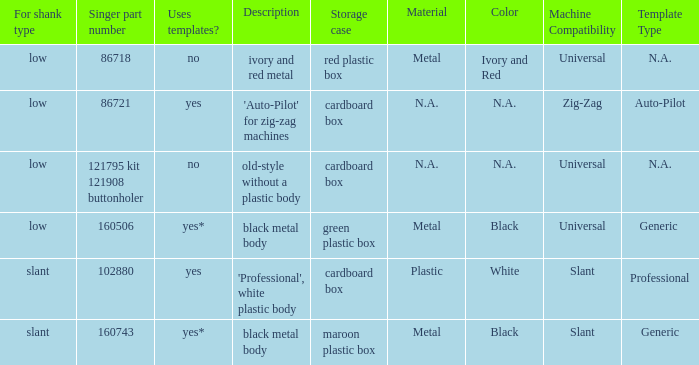Parse the table in full. {'header': ['For shank type', 'Singer part number', 'Uses templates?', 'Description', 'Storage case', 'Material', 'Color', 'Machine Compatibility', 'Template Type '], 'rows': [['low', '86718', 'no', 'ivory and red metal', 'red plastic box', 'Metal', 'Ivory and Red', 'Universal', 'N.A.'], ['low', '86721', 'yes', "'Auto-Pilot' for zig-zag machines", 'cardboard box', 'N.A.', 'N.A.', 'Zig-Zag', 'Auto-Pilot'], ['low', '121795 kit 121908 buttonholer', 'no', 'old-style without a plastic body', 'cardboard box', 'N.A.', 'N.A.', 'Universal', 'N.A.'], ['low', '160506', 'yes*', 'black metal body', 'green plastic box', 'Metal', 'Black', 'Universal', 'Generic '], ['slant', '102880', 'yes', "'Professional', white plastic body", 'cardboard box', 'Plastic', 'White', 'Slant', 'Professional '], ['slant', '160743', 'yes*', 'black metal body', 'maroon plastic box', 'Metal', 'Black', 'Slant', 'Generic']]} What's the description of the buttonholer whose singer part number is 121795 kit 121908 buttonholer? Old-style without a plastic body. 